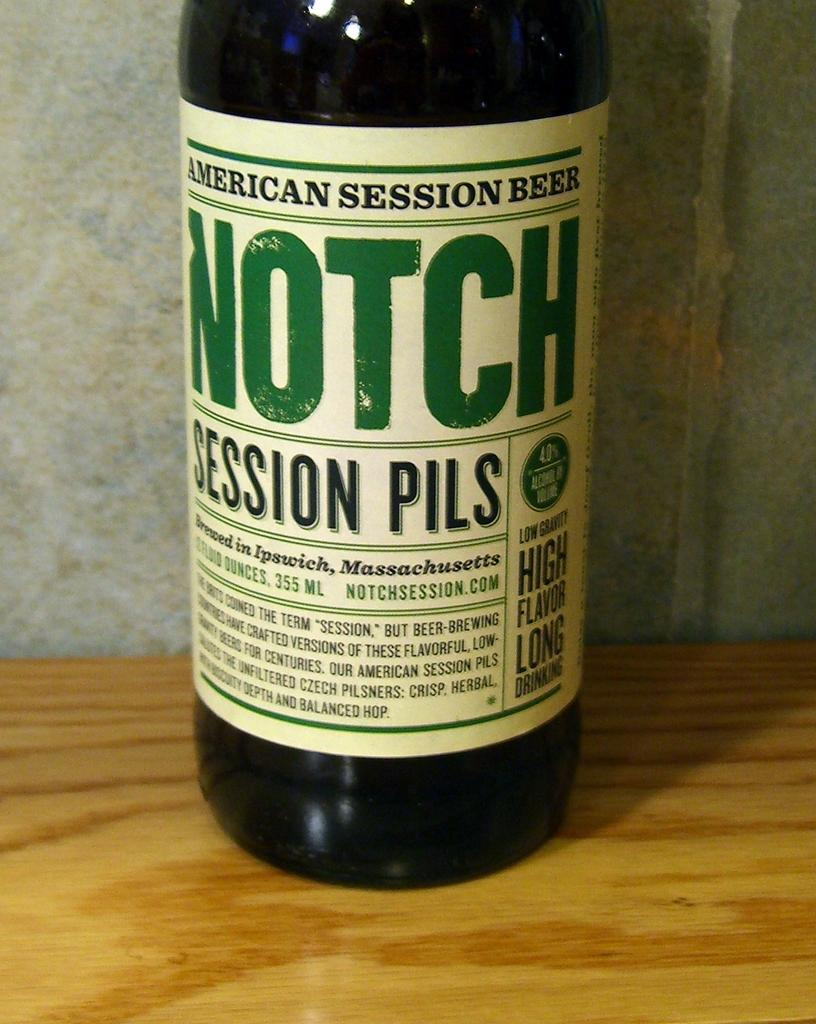<image>
Present a compact description of the photo's key features. Black bottle, whilte label with black and green lettering says AMERICAN SESSION BEER NOTCH SESSION PILS 